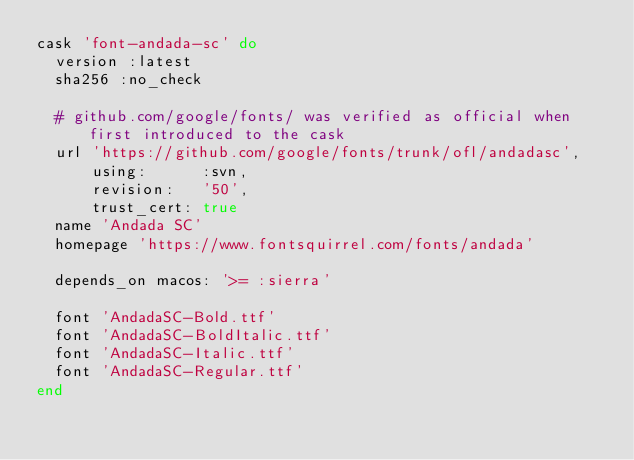Convert code to text. <code><loc_0><loc_0><loc_500><loc_500><_Ruby_>cask 'font-andada-sc' do
  version :latest
  sha256 :no_check

  # github.com/google/fonts/ was verified as official when first introduced to the cask
  url 'https://github.com/google/fonts/trunk/ofl/andadasc',
      using:      :svn,
      revision:   '50',
      trust_cert: true
  name 'Andada SC'
  homepage 'https://www.fontsquirrel.com/fonts/andada'

  depends_on macos: '>= :sierra'

  font 'AndadaSC-Bold.ttf'
  font 'AndadaSC-BoldItalic.ttf'
  font 'AndadaSC-Italic.ttf'
  font 'AndadaSC-Regular.ttf'
end
</code> 